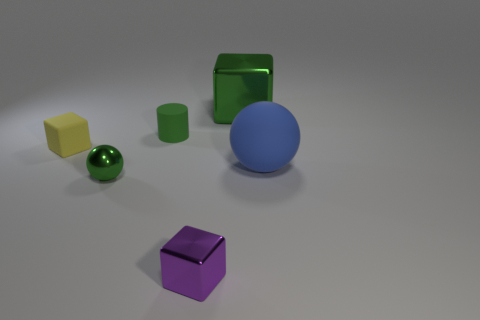Subtract all blue spheres. Subtract all red blocks. How many spheres are left? 1 Subtract all brown spheres. How many yellow cubes are left? 1 Add 4 things. How many big blues exist? 0 Subtract all large balls. Subtract all small green blocks. How many objects are left? 5 Add 4 green rubber objects. How many green rubber objects are left? 5 Add 3 blue matte balls. How many blue matte balls exist? 4 Add 4 gray rubber objects. How many objects exist? 10 Subtract all yellow cubes. How many cubes are left? 2 Subtract all tiny cubes. How many cubes are left? 1 Subtract 0 cyan cylinders. How many objects are left? 6 